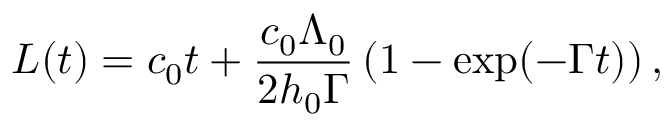Convert formula to latex. <formula><loc_0><loc_0><loc_500><loc_500>L ( t ) = c _ { 0 } t + \frac { c _ { 0 } \Lambda _ { 0 } } { 2 h _ { 0 } \Gamma } \left ( 1 - \exp ( - \Gamma t ) \right ) ,</formula> 